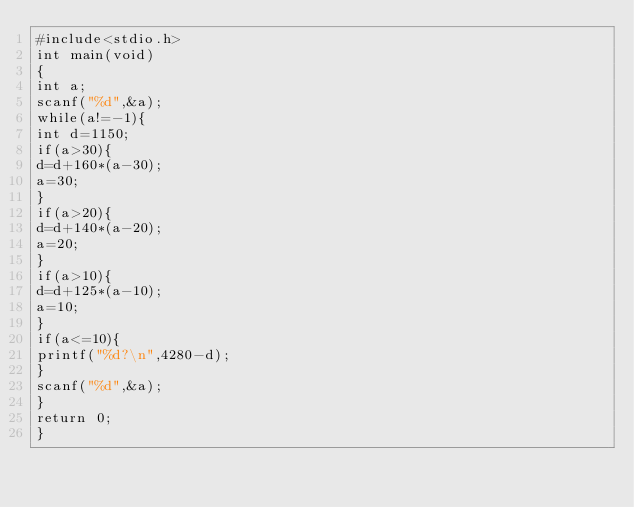Convert code to text. <code><loc_0><loc_0><loc_500><loc_500><_C_>#include<stdio.h>
int main(void)
{
int a;
scanf("%d",&a);
while(a!=-1){
int d=1150;
if(a>30){
d=d+160*(a-30);
a=30;
}
if(a>20){
d=d+140*(a-20);
a=20;
}
if(a>10){
d=d+125*(a-10);
a=10;
}
if(a<=10){
printf("%d?\n",4280-d);
}
scanf("%d",&a);
}
return 0;
}</code> 